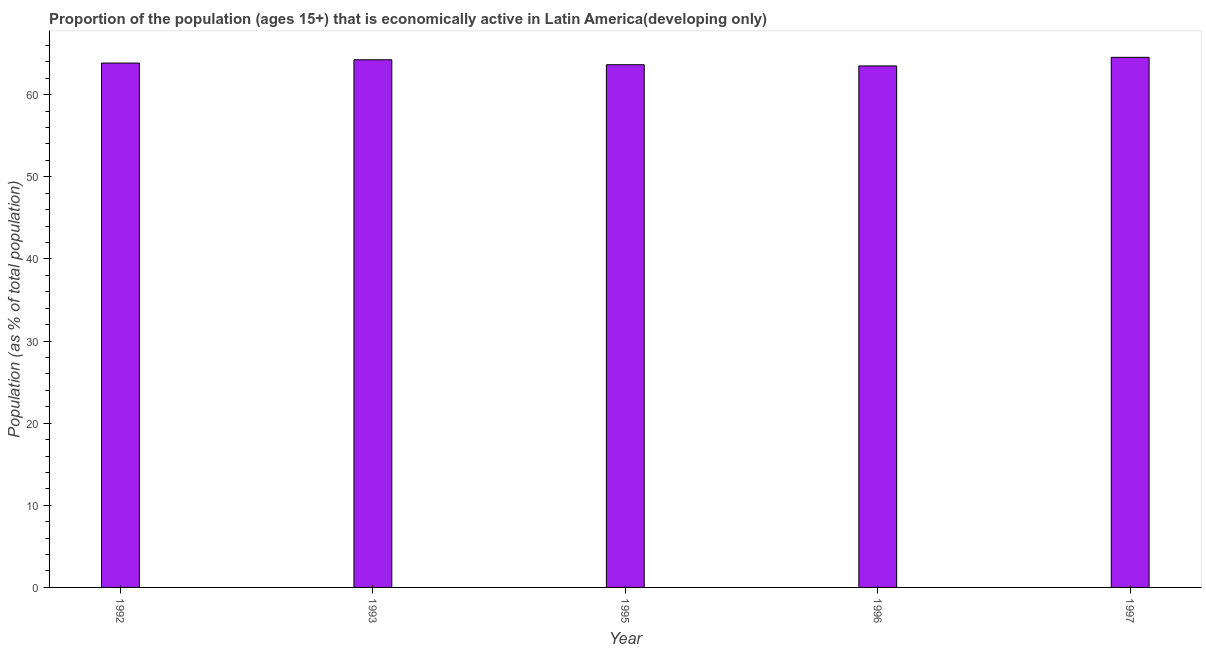What is the title of the graph?
Provide a succinct answer. Proportion of the population (ages 15+) that is economically active in Latin America(developing only). What is the label or title of the Y-axis?
Your answer should be compact. Population (as % of total population). What is the percentage of economically active population in 1996?
Give a very brief answer. 63.49. Across all years, what is the maximum percentage of economically active population?
Offer a very short reply. 64.54. Across all years, what is the minimum percentage of economically active population?
Your answer should be very brief. 63.49. In which year was the percentage of economically active population maximum?
Make the answer very short. 1997. What is the sum of the percentage of economically active population?
Keep it short and to the point. 319.76. What is the difference between the percentage of economically active population in 1992 and 1993?
Keep it short and to the point. -0.4. What is the average percentage of economically active population per year?
Give a very brief answer. 63.95. What is the median percentage of economically active population?
Your answer should be compact. 63.84. In how many years, is the percentage of economically active population greater than 10 %?
Your response must be concise. 5. Do a majority of the years between 1992 and 1996 (inclusive) have percentage of economically active population greater than 24 %?
Offer a terse response. Yes. What is the difference between the highest and the second highest percentage of economically active population?
Keep it short and to the point. 0.3. Is the sum of the percentage of economically active population in 1993 and 1995 greater than the maximum percentage of economically active population across all years?
Keep it short and to the point. Yes. What is the difference between the highest and the lowest percentage of economically active population?
Your answer should be very brief. 1.05. Are all the bars in the graph horizontal?
Your response must be concise. No. How many years are there in the graph?
Ensure brevity in your answer.  5. What is the Population (as % of total population) in 1992?
Your response must be concise. 63.84. What is the Population (as % of total population) of 1993?
Offer a terse response. 64.24. What is the Population (as % of total population) of 1995?
Offer a very short reply. 63.64. What is the Population (as % of total population) of 1996?
Keep it short and to the point. 63.49. What is the Population (as % of total population) of 1997?
Make the answer very short. 64.54. What is the difference between the Population (as % of total population) in 1992 and 1993?
Provide a short and direct response. -0.4. What is the difference between the Population (as % of total population) in 1992 and 1995?
Make the answer very short. 0.2. What is the difference between the Population (as % of total population) in 1992 and 1996?
Give a very brief answer. 0.35. What is the difference between the Population (as % of total population) in 1992 and 1997?
Give a very brief answer. -0.7. What is the difference between the Population (as % of total population) in 1993 and 1995?
Make the answer very short. 0.6. What is the difference between the Population (as % of total population) in 1993 and 1996?
Give a very brief answer. 0.75. What is the difference between the Population (as % of total population) in 1993 and 1997?
Offer a very short reply. -0.3. What is the difference between the Population (as % of total population) in 1995 and 1996?
Your answer should be very brief. 0.15. What is the difference between the Population (as % of total population) in 1995 and 1997?
Provide a short and direct response. -0.9. What is the difference between the Population (as % of total population) in 1996 and 1997?
Ensure brevity in your answer.  -1.05. What is the ratio of the Population (as % of total population) in 1992 to that in 1996?
Ensure brevity in your answer.  1.01. What is the ratio of the Population (as % of total population) in 1993 to that in 1995?
Give a very brief answer. 1.01. What is the ratio of the Population (as % of total population) in 1995 to that in 1996?
Ensure brevity in your answer.  1. What is the ratio of the Population (as % of total population) in 1996 to that in 1997?
Your answer should be very brief. 0.98. 